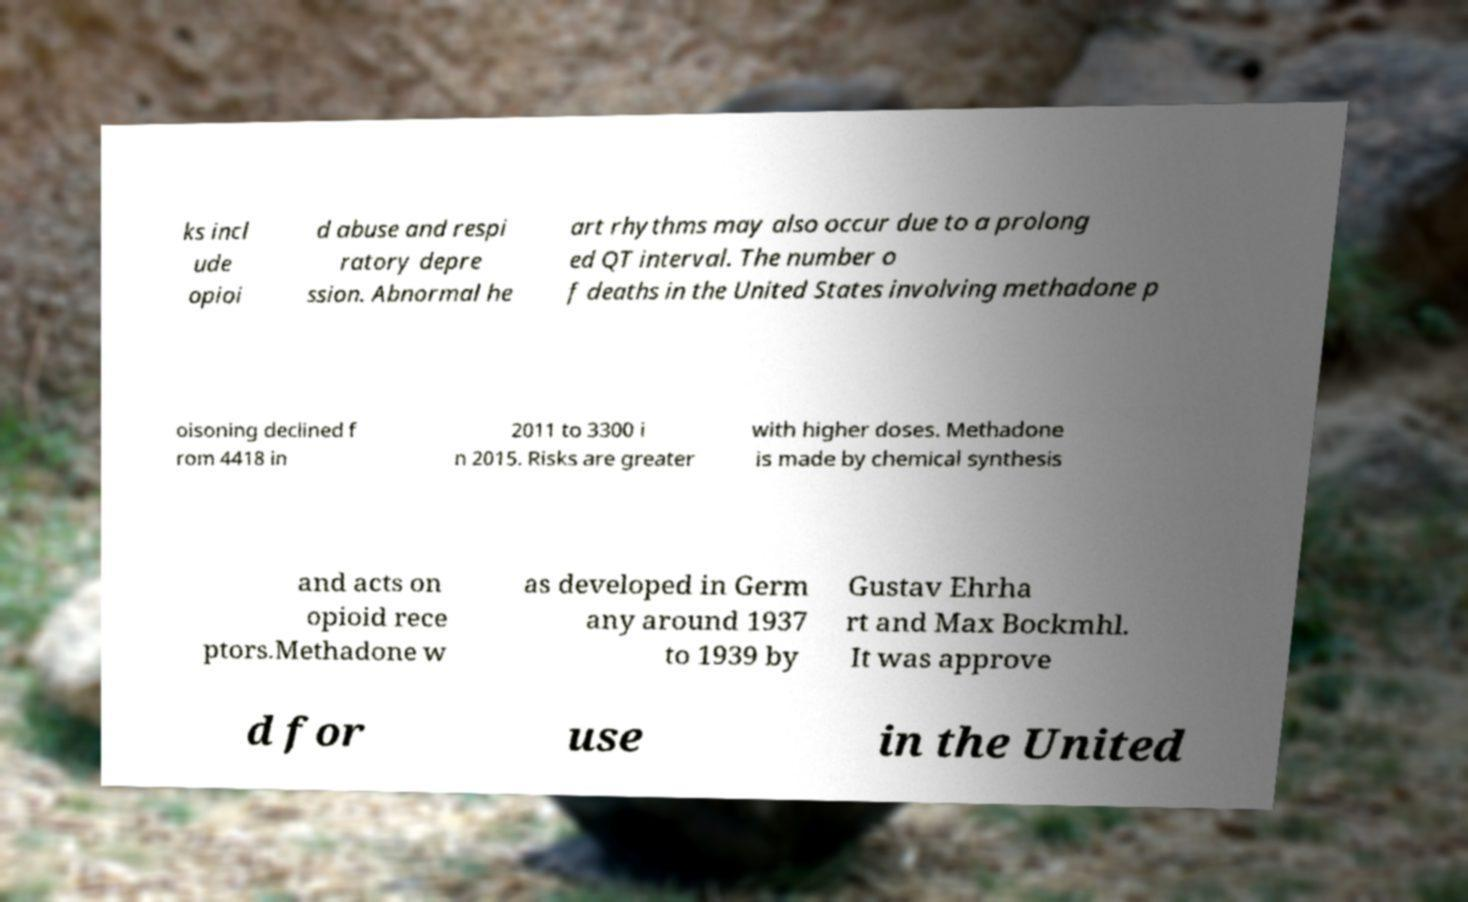I need the written content from this picture converted into text. Can you do that? ks incl ude opioi d abuse and respi ratory depre ssion. Abnormal he art rhythms may also occur due to a prolong ed QT interval. The number o f deaths in the United States involving methadone p oisoning declined f rom 4418 in 2011 to 3300 i n 2015. Risks are greater with higher doses. Methadone is made by chemical synthesis and acts on opioid rece ptors.Methadone w as developed in Germ any around 1937 to 1939 by Gustav Ehrha rt and Max Bockmhl. It was approve d for use in the United 